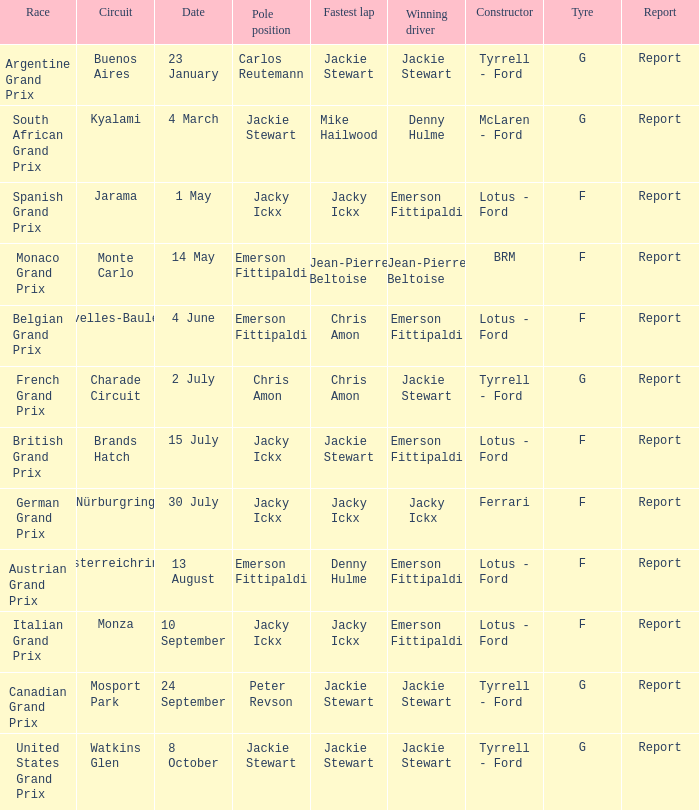What circuit was the British Grand Prix? Brands Hatch. 